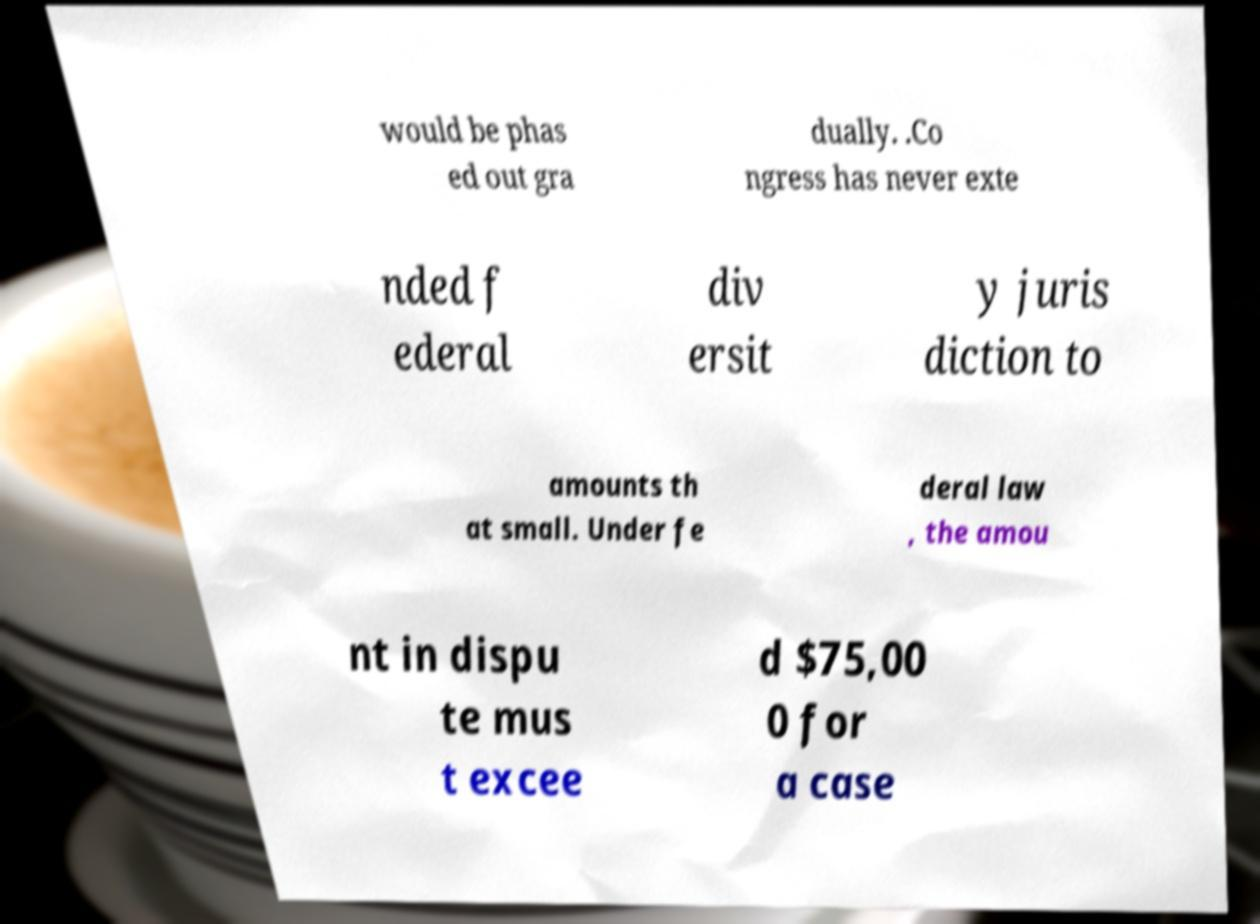Can you accurately transcribe the text from the provided image for me? would be phas ed out gra dually. .Co ngress has never exte nded f ederal div ersit y juris diction to amounts th at small. Under fe deral law , the amou nt in dispu te mus t excee d $75,00 0 for a case 